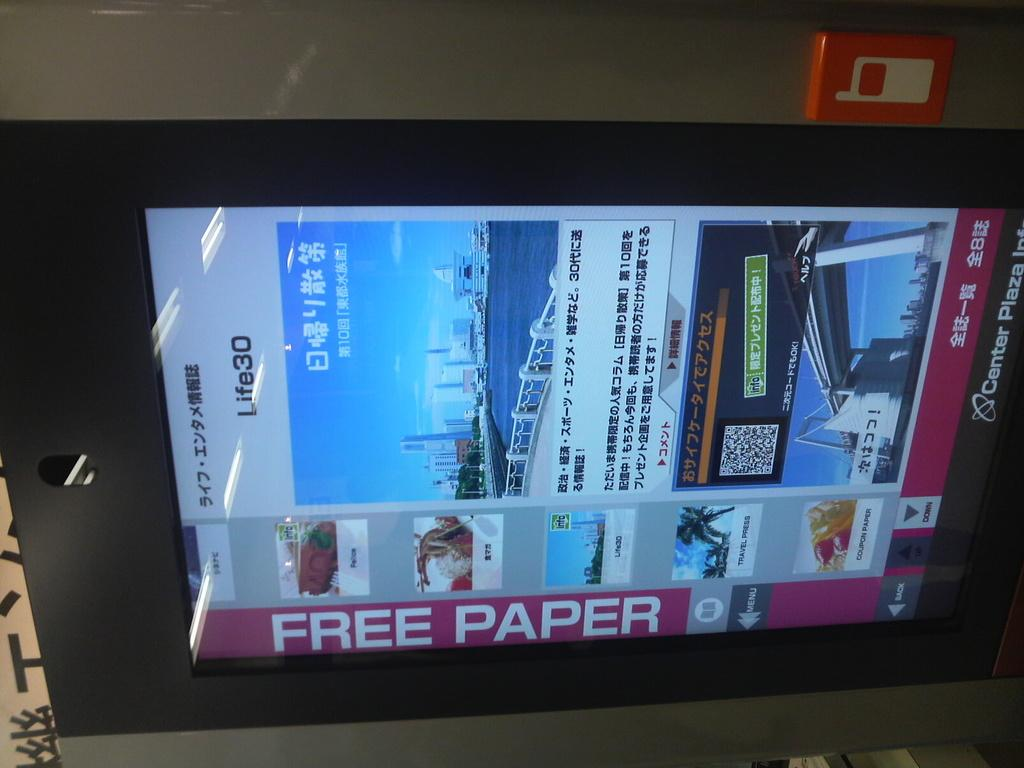<image>
Give a short and clear explanation of the subsequent image. An electronic display of a free paper ad on the bottom 